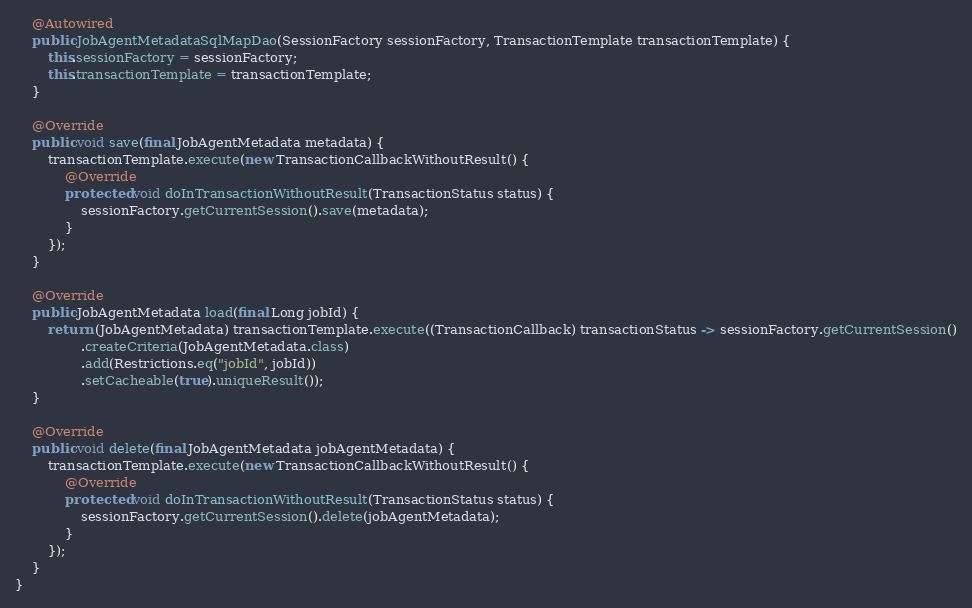<code> <loc_0><loc_0><loc_500><loc_500><_Java_>    @Autowired
    public JobAgentMetadataSqlMapDao(SessionFactory sessionFactory, TransactionTemplate transactionTemplate) {
        this.sessionFactory = sessionFactory;
        this.transactionTemplate = transactionTemplate;
    }

    @Override
    public void save(final JobAgentMetadata metadata) {
        transactionTemplate.execute(new TransactionCallbackWithoutResult() {
            @Override
            protected void doInTransactionWithoutResult(TransactionStatus status) {
                sessionFactory.getCurrentSession().save(metadata);
            }
        });
    }

    @Override
    public JobAgentMetadata load(final Long jobId) {
        return (JobAgentMetadata) transactionTemplate.execute((TransactionCallback) transactionStatus -> sessionFactory.getCurrentSession()
                .createCriteria(JobAgentMetadata.class)
                .add(Restrictions.eq("jobId", jobId))
                .setCacheable(true).uniqueResult());
    }

    @Override
    public void delete(final JobAgentMetadata jobAgentMetadata) {
        transactionTemplate.execute(new TransactionCallbackWithoutResult() {
            @Override
            protected void doInTransactionWithoutResult(TransactionStatus status) {
                sessionFactory.getCurrentSession().delete(jobAgentMetadata);
            }
        });
    }
}
</code> 